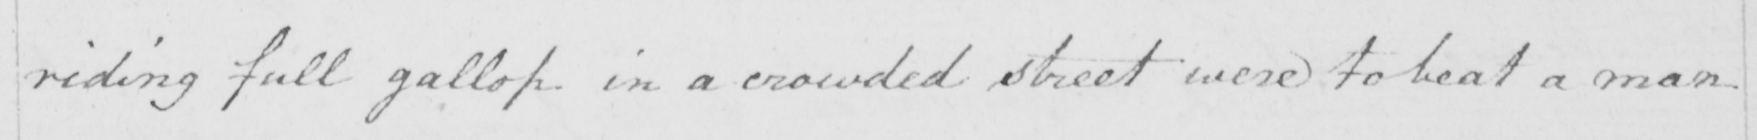Please provide the text content of this handwritten line. riding full gallop in a crowded street were to beat a man 